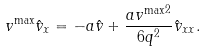Convert formula to latex. <formula><loc_0><loc_0><loc_500><loc_500>v ^ { \max } \hat { v } _ { x } = - a \hat { v } + \frac { a { v ^ { \max } } ^ { 2 } } { 6 q ^ { 2 } } \hat { v } _ { x x } .</formula> 